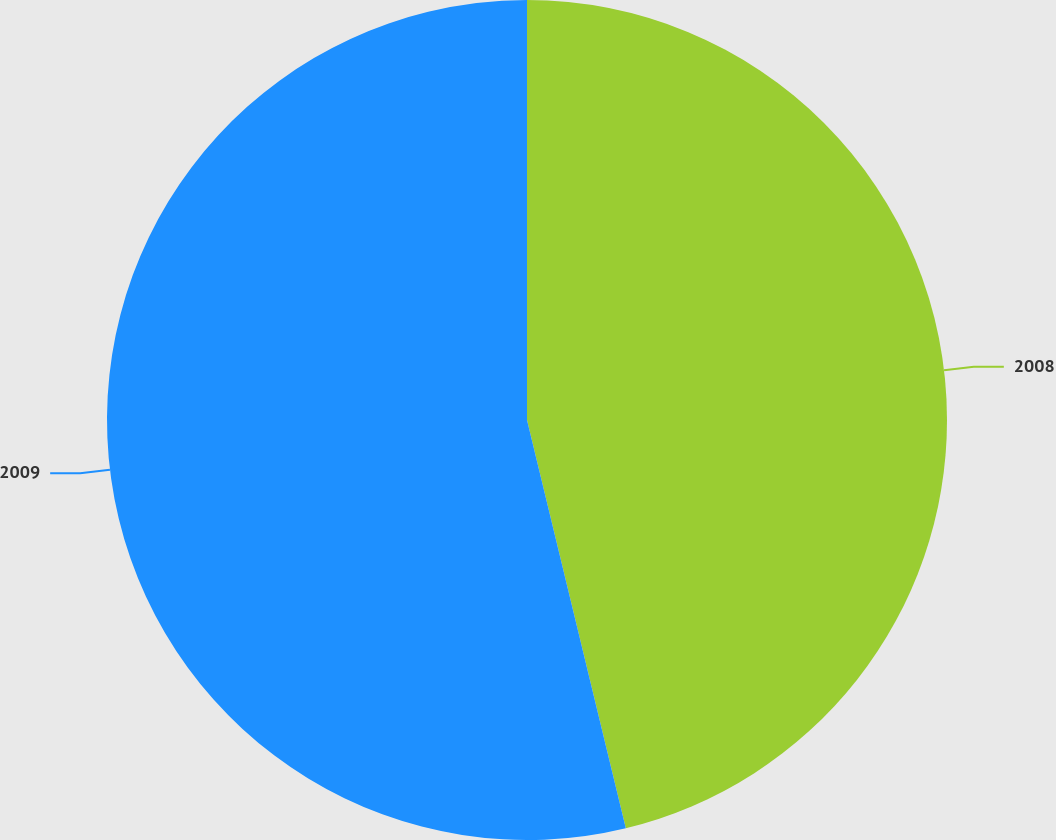<chart> <loc_0><loc_0><loc_500><loc_500><pie_chart><fcel>2008<fcel>2009<nl><fcel>46.22%<fcel>53.78%<nl></chart> 